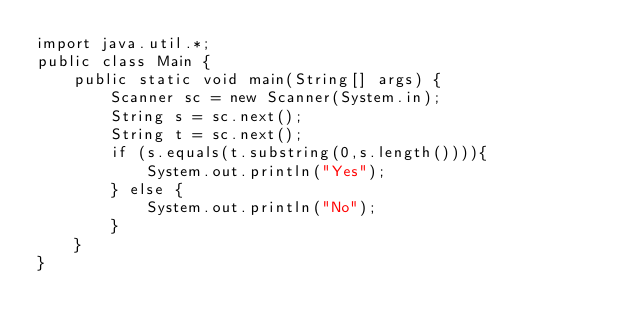Convert code to text. <code><loc_0><loc_0><loc_500><loc_500><_Java_>import java.util.*;
public class Main {
    public static void main(String[] args) {
        Scanner sc = new Scanner(System.in);
        String s = sc.next();
        String t = sc.next();
        if (s.equals(t.substring(0,s.length()))){
            System.out.println("Yes");
        } else {
            System.out.println("No");
        }
    }
}</code> 